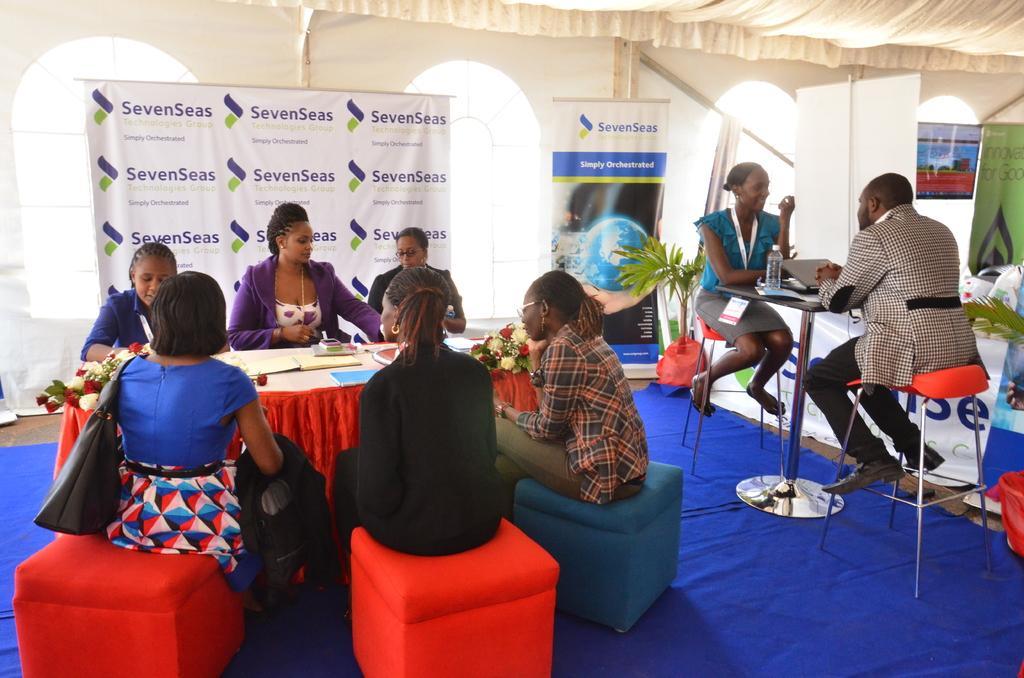Could you give a brief overview of what you see in this image? On the right two persons are sitting on the chair and talking each other on the left six persons are sitting around a table behind them there is a banner. 